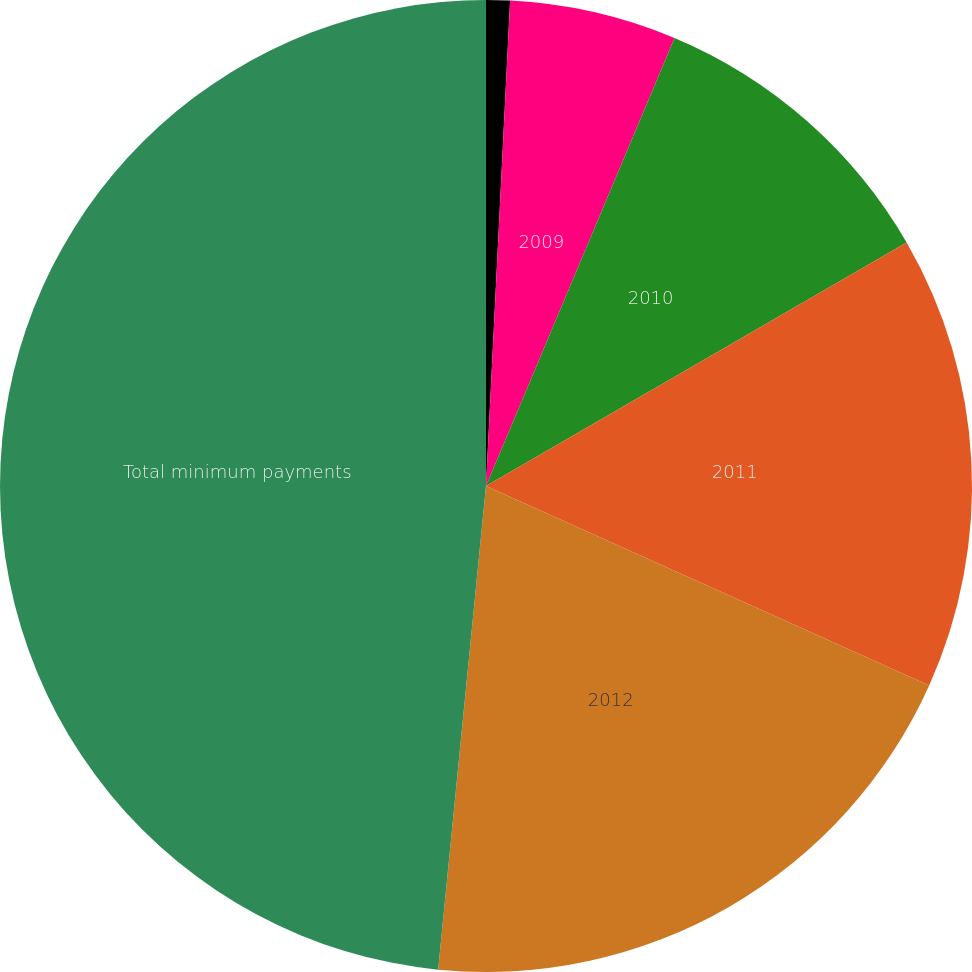Convert chart to OTSL. <chart><loc_0><loc_0><loc_500><loc_500><pie_chart><fcel>2008<fcel>2009<fcel>2010<fcel>2011<fcel>2012<fcel>Total minimum payments<nl><fcel>0.79%<fcel>5.55%<fcel>10.31%<fcel>15.08%<fcel>19.84%<fcel>48.43%<nl></chart> 